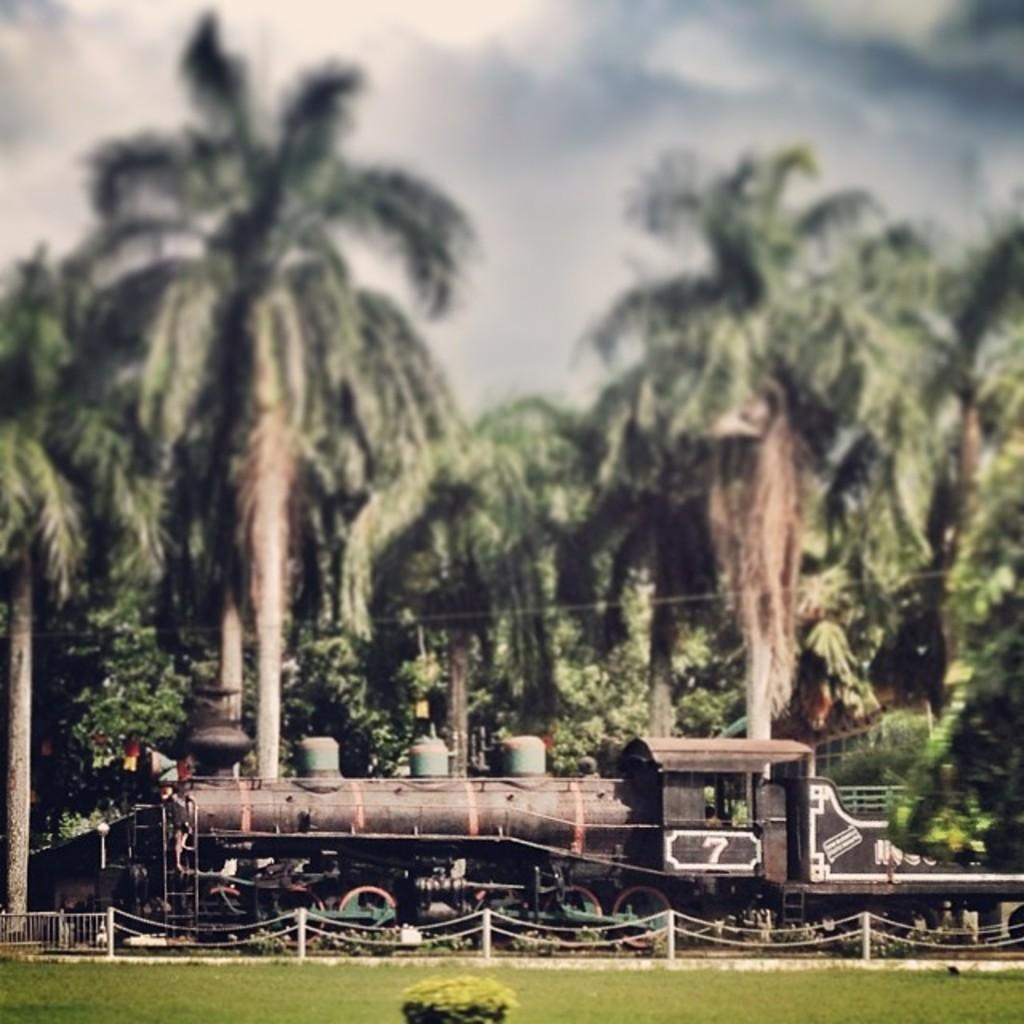What type of structure can be seen in the image? There is a railing and poles in the image, which suggests a railway or train station. What are the metal chains used for in the image? The metal chains are likely used to secure or support the railing or other structures in the image. What mode of transportation is present in the image? There is a train in the image. What can be seen in the background of the image? There is a shed, many trees, clouds, and the sky visible in the background of the image. What idea does the paint on the train represent in the image? There is no mention of paint or any ideas represented by it in the image. The train is simply present as a mode of transportation. 